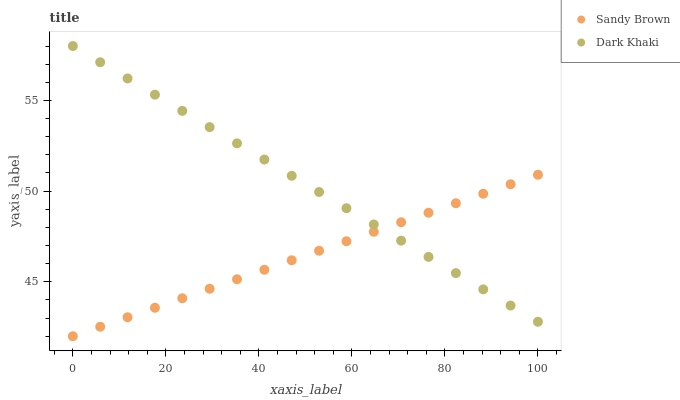Does Sandy Brown have the minimum area under the curve?
Answer yes or no. Yes. Does Dark Khaki have the maximum area under the curve?
Answer yes or no. Yes. Does Sandy Brown have the maximum area under the curve?
Answer yes or no. No. Is Sandy Brown the smoothest?
Answer yes or no. Yes. Is Dark Khaki the roughest?
Answer yes or no. Yes. Is Sandy Brown the roughest?
Answer yes or no. No. Does Sandy Brown have the lowest value?
Answer yes or no. Yes. Does Dark Khaki have the highest value?
Answer yes or no. Yes. Does Sandy Brown have the highest value?
Answer yes or no. No. Does Dark Khaki intersect Sandy Brown?
Answer yes or no. Yes. Is Dark Khaki less than Sandy Brown?
Answer yes or no. No. Is Dark Khaki greater than Sandy Brown?
Answer yes or no. No. 